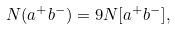<formula> <loc_0><loc_0><loc_500><loc_500>N ( a ^ { + } b ^ { - } ) = 9 N [ a ^ { + } b ^ { - } ] ,</formula> 